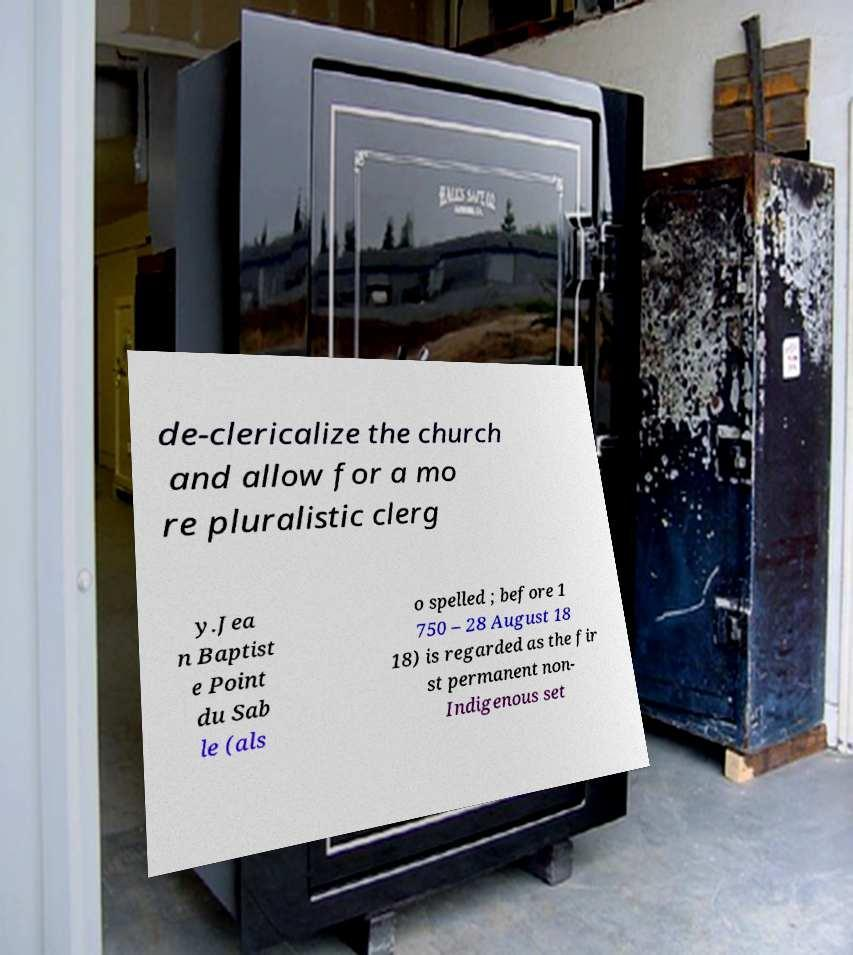Can you accurately transcribe the text from the provided image for me? de-clericalize the church and allow for a mo re pluralistic clerg y.Jea n Baptist e Point du Sab le (als o spelled ; before 1 750 – 28 August 18 18) is regarded as the fir st permanent non- Indigenous set 